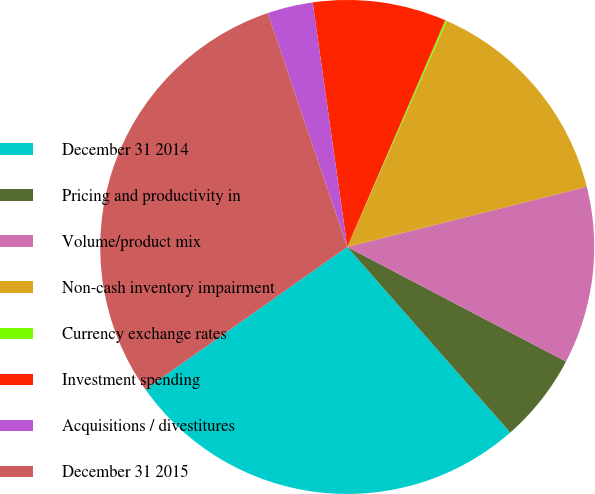<chart> <loc_0><loc_0><loc_500><loc_500><pie_chart><fcel>December 31 2014<fcel>Pricing and productivity in<fcel>Volume/product mix<fcel>Non-cash inventory impairment<fcel>Currency exchange rates<fcel>Investment spending<fcel>Acquisitions / divestitures<fcel>December 31 2015<nl><fcel>26.69%<fcel>5.85%<fcel>11.6%<fcel>14.47%<fcel>0.11%<fcel>8.73%<fcel>2.98%<fcel>29.56%<nl></chart> 